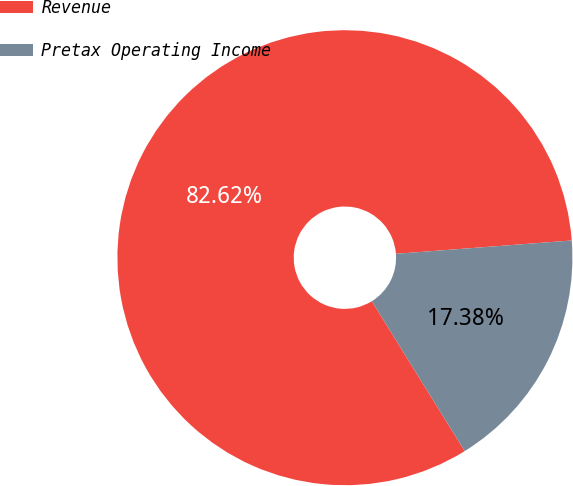<chart> <loc_0><loc_0><loc_500><loc_500><pie_chart><fcel>Revenue<fcel>Pretax Operating Income<nl><fcel>82.62%<fcel>17.38%<nl></chart> 